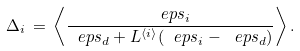Convert formula to latex. <formula><loc_0><loc_0><loc_500><loc_500>\Delta _ { i } \, = \, \left \langle \frac { \ e p s _ { i } } { \ e p s _ { d } + L ^ { \langle i \rangle } ( \ e p s _ { i } - \ e p s _ { d } ) } \right \rangle .</formula> 